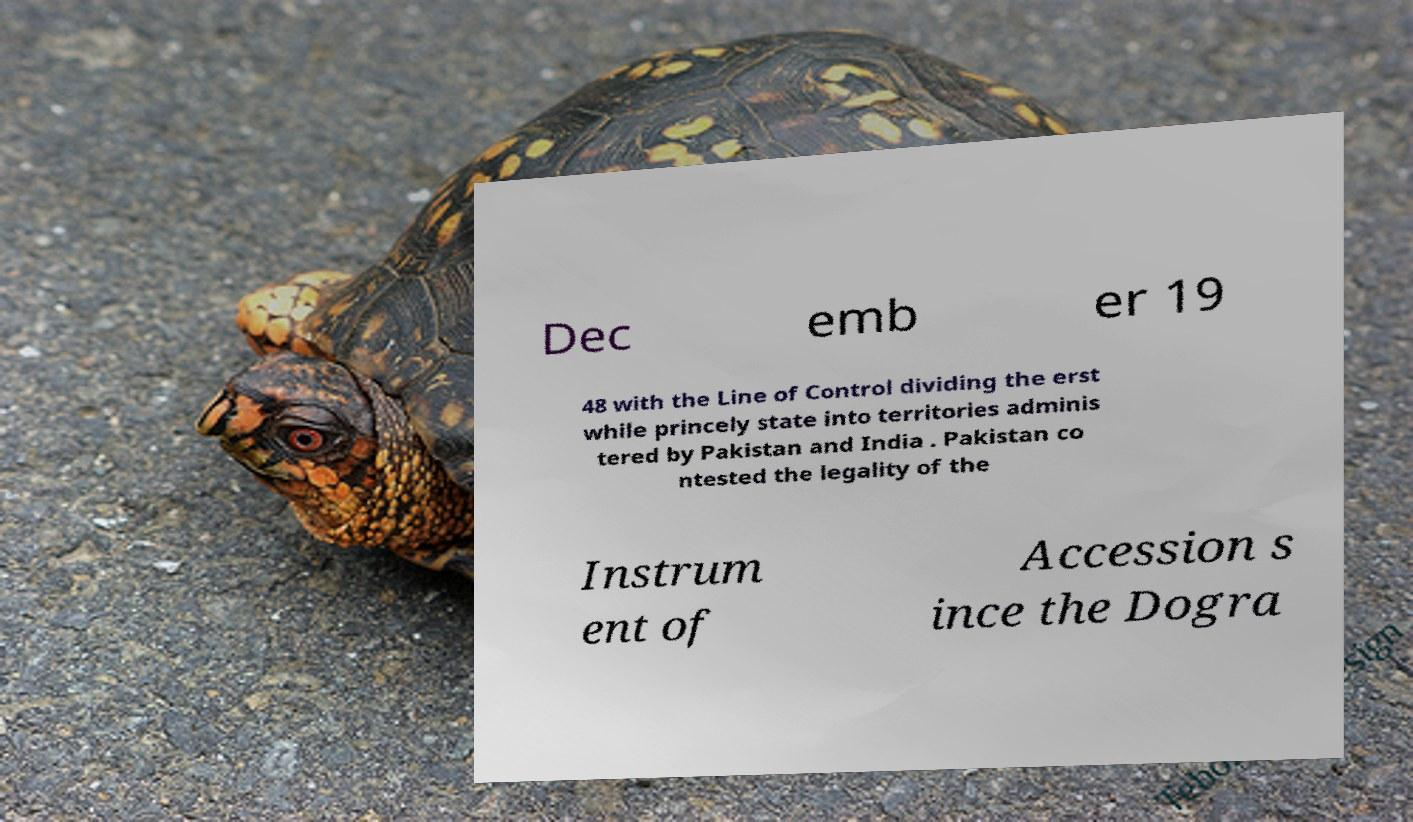Can you read and provide the text displayed in the image?This photo seems to have some interesting text. Can you extract and type it out for me? Dec emb er 19 48 with the Line of Control dividing the erst while princely state into territories adminis tered by Pakistan and India . Pakistan co ntested the legality of the Instrum ent of Accession s ince the Dogra 